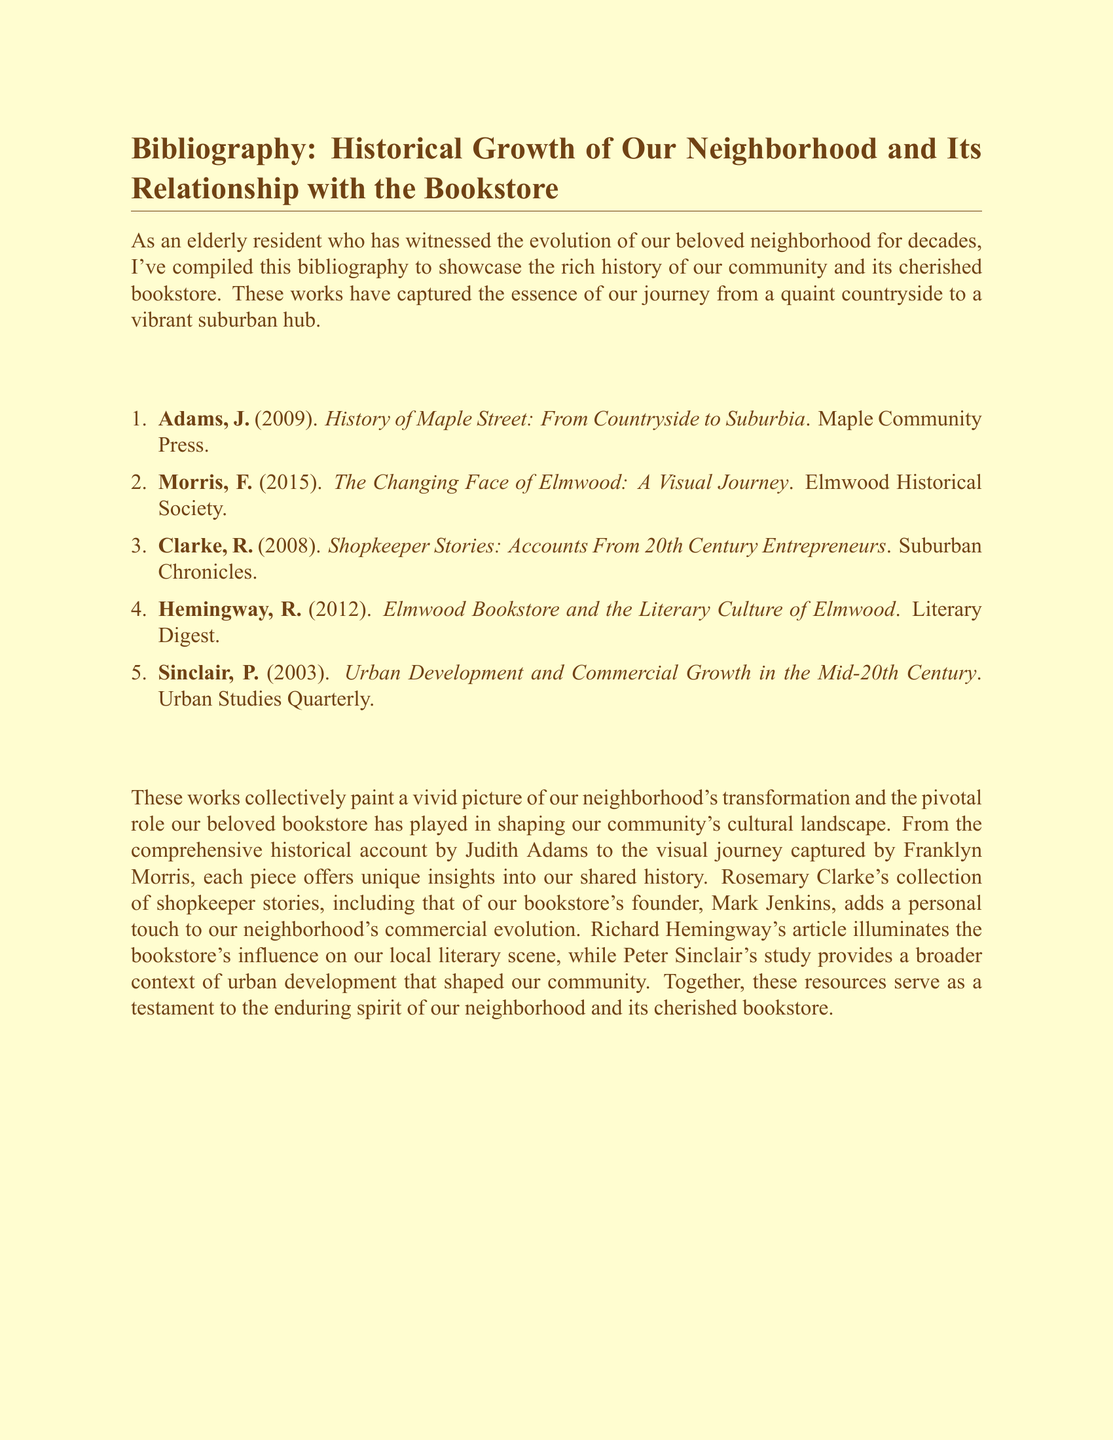What is the title of Judith Adams' work? Judith Adams' work is titled "History of Maple Street: From Countryside to Suburbia."
Answer: "History of Maple Street: From Countryside to Suburbia" Who wrote "The Changing Face of Elmwood"? The author of "The Changing Face of Elmwood" is Franklyn Morris.
Answer: Franklyn Morris In what year was "Shopkeeper Stories" published? "Shopkeeper Stories: Accounts From 20th Century Entrepreneurs" was published in 2008.
Answer: 2008 What is the main topic of Richard Hemingway's article? Richard Hemingway's article discusses the influence of the Elmwood bookstore on the local literary scene.
Answer: Local literary scene Which publication features Rosemary Clarke's accounts? Rosemary Clarke's accounts are featured in "Shopkeeper Stories: Accounts From 20th Century Entrepreneurs."
Answer: Shopkeeper Stories: Accounts From 20th Century Entrepreneurs How many entries are in the bibliography? There are five entries in the bibliography.
Answer: Five What color is the document's background? The document's background is cream.
Answer: Cream Who is mentioned as the founder of the bookstore? Mark Jenkins is mentioned as the founder of the bookstore.
Answer: Mark Jenkins 